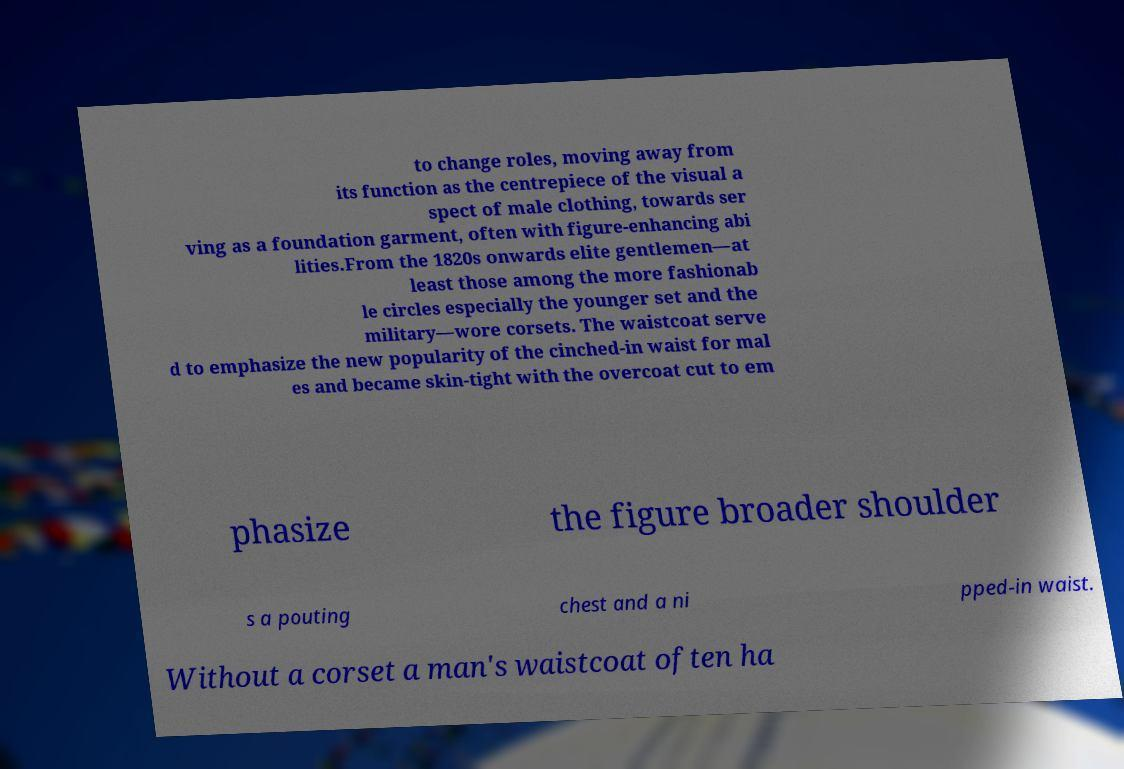Could you extract and type out the text from this image? to change roles, moving away from its function as the centrepiece of the visual a spect of male clothing, towards ser ving as a foundation garment, often with figure-enhancing abi lities.From the 1820s onwards elite gentlemen—at least those among the more fashionab le circles especially the younger set and the military—wore corsets. The waistcoat serve d to emphasize the new popularity of the cinched-in waist for mal es and became skin-tight with the overcoat cut to em phasize the figure broader shoulder s a pouting chest and a ni pped-in waist. Without a corset a man's waistcoat often ha 